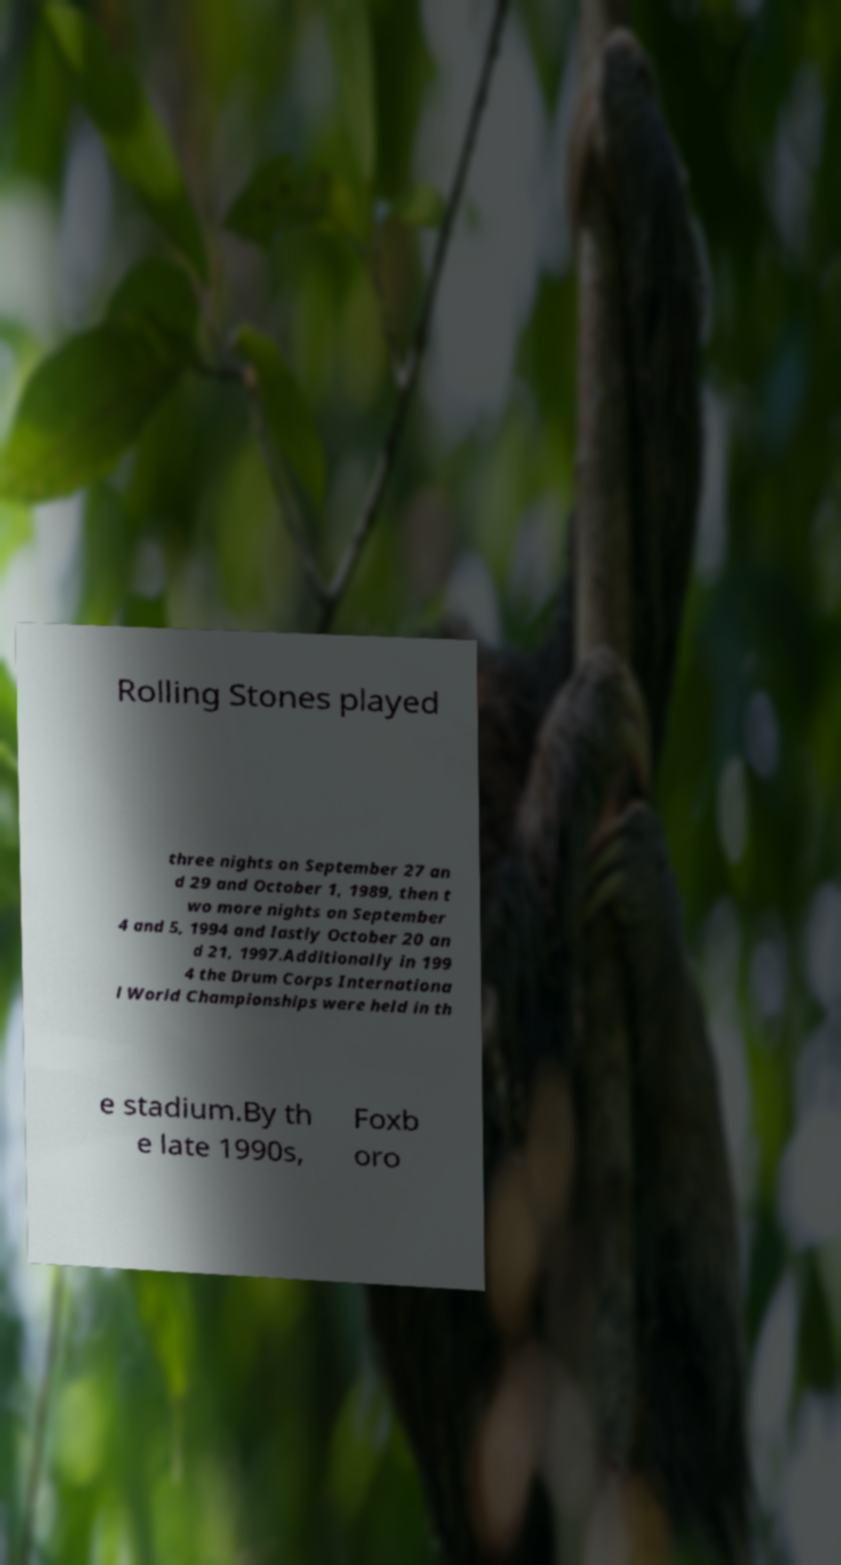Please read and relay the text visible in this image. What does it say? Rolling Stones played three nights on September 27 an d 29 and October 1, 1989, then t wo more nights on September 4 and 5, 1994 and lastly October 20 an d 21, 1997.Additionally in 199 4 the Drum Corps Internationa l World Championships were held in th e stadium.By th e late 1990s, Foxb oro 